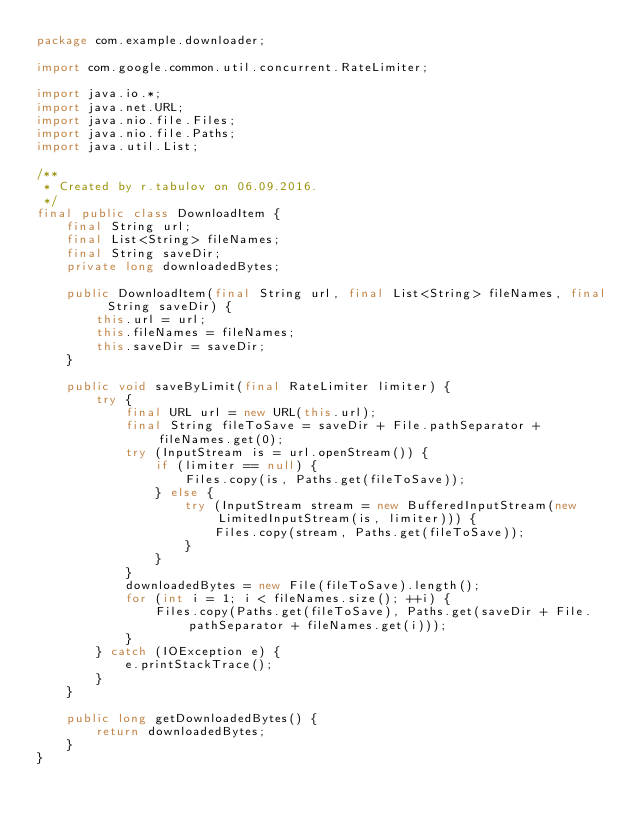Convert code to text. <code><loc_0><loc_0><loc_500><loc_500><_Java_>package com.example.downloader;

import com.google.common.util.concurrent.RateLimiter;

import java.io.*;
import java.net.URL;
import java.nio.file.Files;
import java.nio.file.Paths;
import java.util.List;

/**
 * Created by r.tabulov on 06.09.2016.
 */
final public class DownloadItem {
    final String url;
    final List<String> fileNames;
    final String saveDir;
    private long downloadedBytes;

    public DownloadItem(final String url, final List<String> fileNames, final String saveDir) {
        this.url = url;
        this.fileNames = fileNames;
        this.saveDir = saveDir;
    }

    public void saveByLimit(final RateLimiter limiter) {
        try {
            final URL url = new URL(this.url);
            final String fileToSave = saveDir + File.pathSeparator + fileNames.get(0);
            try (InputStream is = url.openStream()) {
                if (limiter == null) {
                    Files.copy(is, Paths.get(fileToSave));
                } else {
                    try (InputStream stream = new BufferedInputStream(new LimitedInputStream(is, limiter))) {
                        Files.copy(stream, Paths.get(fileToSave));
                    }
                }
            }
            downloadedBytes = new File(fileToSave).length();
            for (int i = 1; i < fileNames.size(); ++i) {
                Files.copy(Paths.get(fileToSave), Paths.get(saveDir + File.pathSeparator + fileNames.get(i)));
            }
        } catch (IOException e) {
            e.printStackTrace();
        }
    }

    public long getDownloadedBytes() {
        return downloadedBytes;
    }
}
</code> 